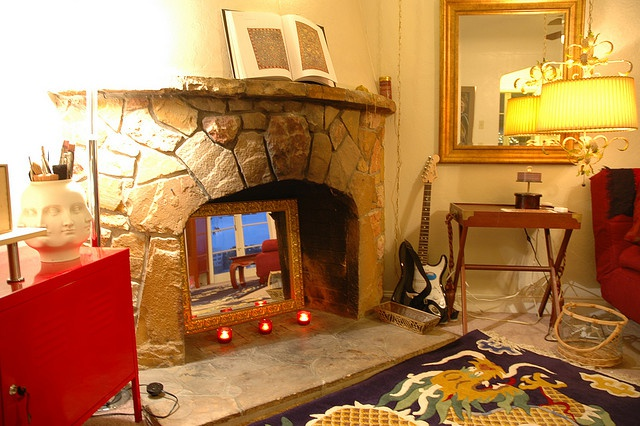Describe the objects in this image and their specific colors. I can see book in white, khaki, tan, and olive tones, couch in white, maroon, black, and olive tones, chair in white, maroon, black, and brown tones, and vase in white, tan, khaki, lightyellow, and red tones in this image. 